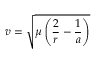<formula> <loc_0><loc_0><loc_500><loc_500>v = { \sqrt { \mu \left ( { \frac { 2 } { r } } - { \frac { 1 } { a } } \right ) } }</formula> 